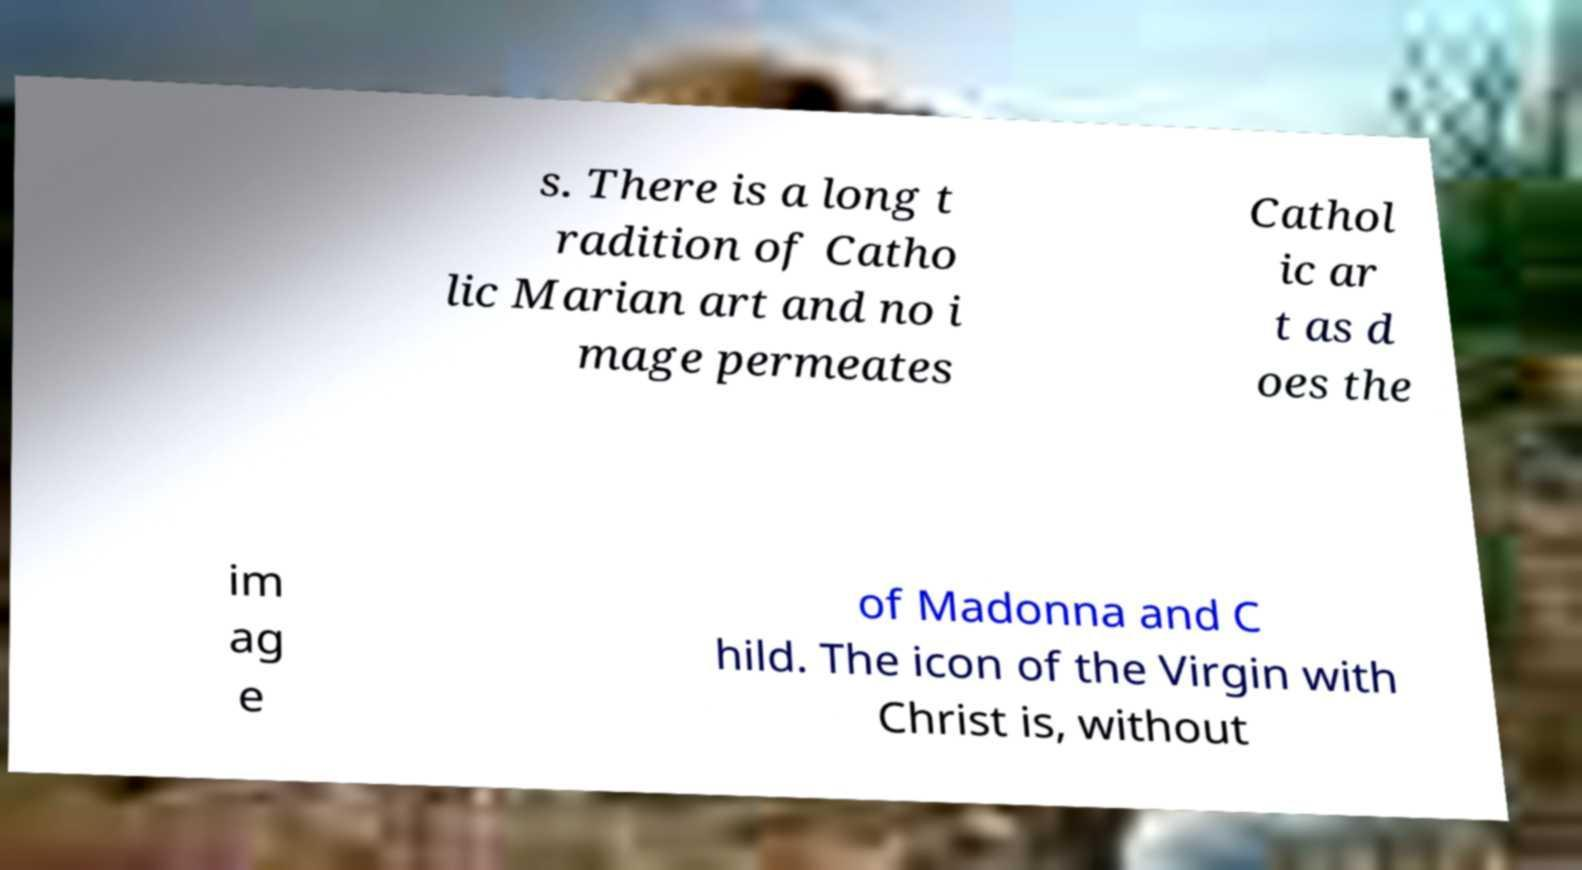For documentation purposes, I need the text within this image transcribed. Could you provide that? s. There is a long t radition of Catho lic Marian art and no i mage permeates Cathol ic ar t as d oes the im ag e of Madonna and C hild. The icon of the Virgin with Christ is, without 